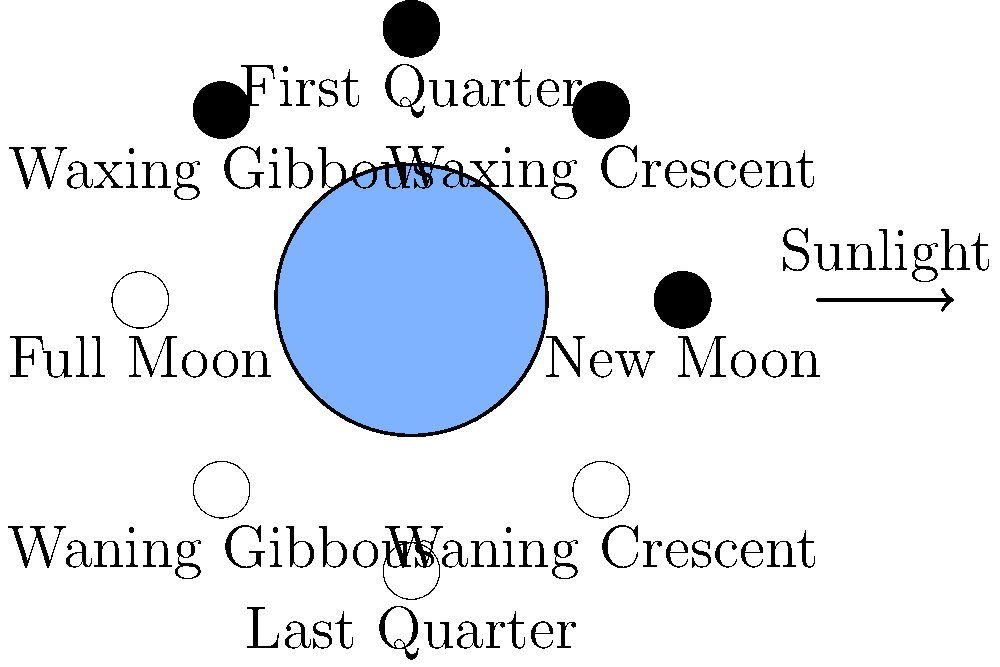As a librarian organizing a "Science in Pop Culture" event, you're creating a trivia game about astronomy references in sitcoms. Which phase of the Moon would be visible from Earth when it's located directly between the Earth and the Sun, as often dramatically depicted in TV shows featuring lunar eclipses? Let's break this down step-by-step:

1. The Moon's phases are determined by the relative positions of the Sun, Earth, and Moon.

2. When the Moon is directly between the Earth and the Sun, it's in the position labeled "New Moon" in the diagram.

3. At this position:
   - The side of the Moon facing the Earth is completely in shadow.
   - The sunlit side of the Moon is facing away from Earth.

4. From Earth's perspective, the Moon appears dark or invisible during this phase.

5. This is why solar eclipses can only occur during a New Moon - the Moon must be between the Earth and Sun to cast its shadow on Earth.

6. However, it's important to note that a New Moon doesn't always result in a solar eclipse. The Moon's orbit is slightly tilted relative to Earth's orbit around the Sun, so most New Moons pass above or below the Sun from Earth's perspective.

7. In TV shows, lunar eclipses (when Earth's shadow falls on the Moon) are often confused with solar eclipses. Lunar eclipses actually occur during a Full Moon, when Earth is between the Sun and Moon.

Therefore, when the Moon is directly between the Earth and the Sun, it would be in the New Moon phase.
Answer: New Moon 